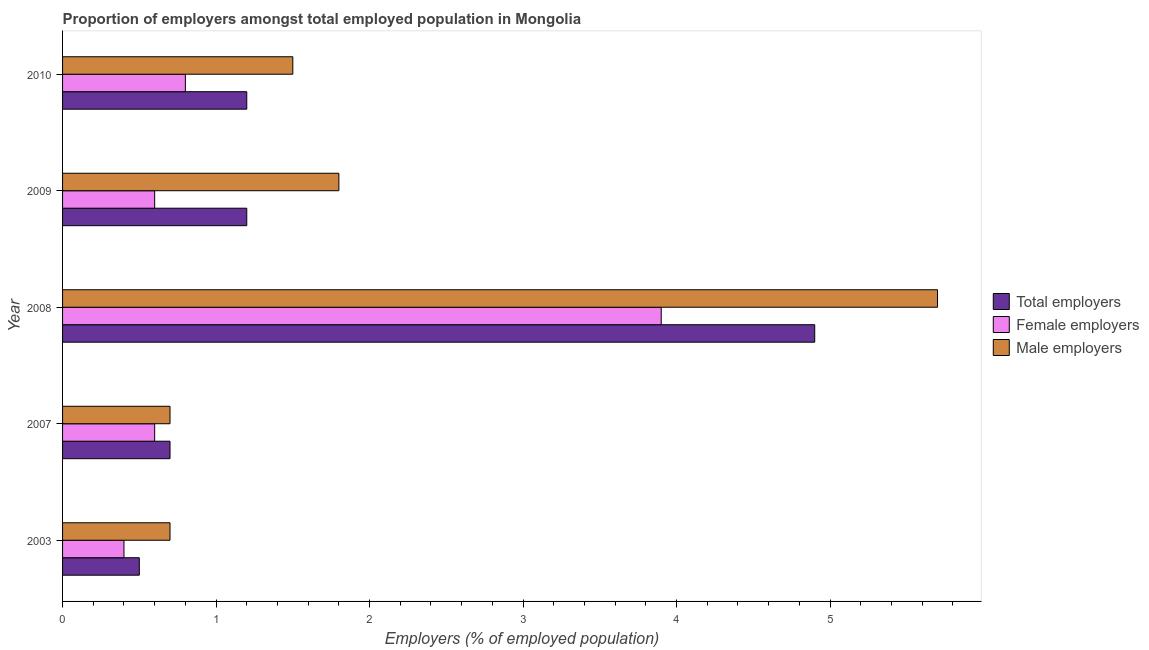Are the number of bars on each tick of the Y-axis equal?
Offer a terse response. Yes. How many bars are there on the 4th tick from the bottom?
Ensure brevity in your answer.  3. In how many cases, is the number of bars for a given year not equal to the number of legend labels?
Your answer should be compact. 0. What is the percentage of female employers in 2007?
Offer a very short reply. 0.6. Across all years, what is the maximum percentage of total employers?
Your answer should be very brief. 4.9. Across all years, what is the minimum percentage of male employers?
Offer a terse response. 0.7. What is the total percentage of female employers in the graph?
Ensure brevity in your answer.  6.3. What is the difference between the percentage of total employers in 2003 and that in 2007?
Provide a short and direct response. -0.2. What is the difference between the percentage of total employers in 2008 and the percentage of female employers in 2009?
Make the answer very short. 4.3. What is the average percentage of male employers per year?
Ensure brevity in your answer.  2.08. In the year 2008, what is the difference between the percentage of female employers and percentage of total employers?
Offer a terse response. -1. In how many years, is the percentage of female employers greater than 3.2 %?
Give a very brief answer. 1. What is the ratio of the percentage of total employers in 2003 to that in 2009?
Make the answer very short. 0.42. Is the percentage of male employers in 2003 less than that in 2009?
Ensure brevity in your answer.  Yes. Is the difference between the percentage of total employers in 2003 and 2010 greater than the difference between the percentage of male employers in 2003 and 2010?
Offer a terse response. Yes. What is the difference between the highest and the second highest percentage of male employers?
Make the answer very short. 3.9. What is the difference between the highest and the lowest percentage of female employers?
Your answer should be very brief. 3.5. Is the sum of the percentage of female employers in 2003 and 2009 greater than the maximum percentage of total employers across all years?
Your answer should be compact. No. What does the 1st bar from the top in 2010 represents?
Offer a very short reply. Male employers. What does the 3rd bar from the bottom in 2010 represents?
Offer a very short reply. Male employers. Are all the bars in the graph horizontal?
Offer a very short reply. Yes. How many years are there in the graph?
Provide a short and direct response. 5. Are the values on the major ticks of X-axis written in scientific E-notation?
Provide a succinct answer. No. Does the graph contain grids?
Keep it short and to the point. No. Where does the legend appear in the graph?
Offer a very short reply. Center right. How are the legend labels stacked?
Your answer should be very brief. Vertical. What is the title of the graph?
Provide a short and direct response. Proportion of employers amongst total employed population in Mongolia. What is the label or title of the X-axis?
Your response must be concise. Employers (% of employed population). What is the label or title of the Y-axis?
Offer a terse response. Year. What is the Employers (% of employed population) in Female employers in 2003?
Make the answer very short. 0.4. What is the Employers (% of employed population) of Male employers in 2003?
Keep it short and to the point. 0.7. What is the Employers (% of employed population) in Total employers in 2007?
Ensure brevity in your answer.  0.7. What is the Employers (% of employed population) of Female employers in 2007?
Offer a terse response. 0.6. What is the Employers (% of employed population) of Male employers in 2007?
Provide a succinct answer. 0.7. What is the Employers (% of employed population) of Total employers in 2008?
Provide a succinct answer. 4.9. What is the Employers (% of employed population) in Female employers in 2008?
Provide a succinct answer. 3.9. What is the Employers (% of employed population) in Male employers in 2008?
Your answer should be compact. 5.7. What is the Employers (% of employed population) of Total employers in 2009?
Your answer should be compact. 1.2. What is the Employers (% of employed population) in Female employers in 2009?
Make the answer very short. 0.6. What is the Employers (% of employed population) of Male employers in 2009?
Offer a terse response. 1.8. What is the Employers (% of employed population) of Total employers in 2010?
Ensure brevity in your answer.  1.2. What is the Employers (% of employed population) in Female employers in 2010?
Give a very brief answer. 0.8. Across all years, what is the maximum Employers (% of employed population) of Total employers?
Your response must be concise. 4.9. Across all years, what is the maximum Employers (% of employed population) in Female employers?
Provide a succinct answer. 3.9. Across all years, what is the maximum Employers (% of employed population) of Male employers?
Provide a succinct answer. 5.7. Across all years, what is the minimum Employers (% of employed population) in Total employers?
Provide a short and direct response. 0.5. Across all years, what is the minimum Employers (% of employed population) of Female employers?
Make the answer very short. 0.4. Across all years, what is the minimum Employers (% of employed population) in Male employers?
Ensure brevity in your answer.  0.7. What is the total Employers (% of employed population) in Total employers in the graph?
Your answer should be very brief. 8.5. What is the difference between the Employers (% of employed population) in Male employers in 2003 and that in 2008?
Your answer should be compact. -5. What is the difference between the Employers (% of employed population) of Female employers in 2007 and that in 2008?
Keep it short and to the point. -3.3. What is the difference between the Employers (% of employed population) of Male employers in 2007 and that in 2008?
Make the answer very short. -5. What is the difference between the Employers (% of employed population) of Female employers in 2007 and that in 2009?
Make the answer very short. 0. What is the difference between the Employers (% of employed population) in Male employers in 2007 and that in 2010?
Your answer should be very brief. -0.8. What is the difference between the Employers (% of employed population) in Total employers in 2008 and that in 2009?
Provide a short and direct response. 3.7. What is the difference between the Employers (% of employed population) of Total employers in 2008 and that in 2010?
Ensure brevity in your answer.  3.7. What is the difference between the Employers (% of employed population) in Female employers in 2008 and that in 2010?
Make the answer very short. 3.1. What is the difference between the Employers (% of employed population) of Male employers in 2008 and that in 2010?
Ensure brevity in your answer.  4.2. What is the difference between the Employers (% of employed population) of Male employers in 2009 and that in 2010?
Your response must be concise. 0.3. What is the difference between the Employers (% of employed population) of Total employers in 2003 and the Employers (% of employed population) of Female employers in 2007?
Provide a short and direct response. -0.1. What is the difference between the Employers (% of employed population) in Total employers in 2003 and the Employers (% of employed population) in Female employers in 2008?
Give a very brief answer. -3.4. What is the difference between the Employers (% of employed population) of Female employers in 2003 and the Employers (% of employed population) of Male employers in 2008?
Keep it short and to the point. -5.3. What is the difference between the Employers (% of employed population) of Total employers in 2003 and the Employers (% of employed population) of Male employers in 2009?
Ensure brevity in your answer.  -1.3. What is the difference between the Employers (% of employed population) in Female employers in 2003 and the Employers (% of employed population) in Male employers in 2009?
Provide a succinct answer. -1.4. What is the difference between the Employers (% of employed population) in Total employers in 2007 and the Employers (% of employed population) in Female employers in 2008?
Offer a very short reply. -3.2. What is the difference between the Employers (% of employed population) of Total employers in 2007 and the Employers (% of employed population) of Male employers in 2008?
Your answer should be compact. -5. What is the difference between the Employers (% of employed population) in Female employers in 2007 and the Employers (% of employed population) in Male employers in 2008?
Offer a very short reply. -5.1. What is the difference between the Employers (% of employed population) in Total employers in 2007 and the Employers (% of employed population) in Female employers in 2009?
Your answer should be compact. 0.1. What is the difference between the Employers (% of employed population) of Total employers in 2007 and the Employers (% of employed population) of Male employers in 2009?
Ensure brevity in your answer.  -1.1. What is the difference between the Employers (% of employed population) of Total employers in 2007 and the Employers (% of employed population) of Female employers in 2010?
Ensure brevity in your answer.  -0.1. What is the difference between the Employers (% of employed population) in Total employers in 2007 and the Employers (% of employed population) in Male employers in 2010?
Make the answer very short. -0.8. What is the difference between the Employers (% of employed population) of Female employers in 2007 and the Employers (% of employed population) of Male employers in 2010?
Provide a succinct answer. -0.9. What is the difference between the Employers (% of employed population) in Total employers in 2008 and the Employers (% of employed population) in Male employers in 2009?
Keep it short and to the point. 3.1. What is the difference between the Employers (% of employed population) of Female employers in 2008 and the Employers (% of employed population) of Male employers in 2010?
Your answer should be very brief. 2.4. What is the difference between the Employers (% of employed population) in Female employers in 2009 and the Employers (% of employed population) in Male employers in 2010?
Ensure brevity in your answer.  -0.9. What is the average Employers (% of employed population) of Female employers per year?
Your response must be concise. 1.26. What is the average Employers (% of employed population) of Male employers per year?
Offer a terse response. 2.08. In the year 2003, what is the difference between the Employers (% of employed population) of Female employers and Employers (% of employed population) of Male employers?
Provide a succinct answer. -0.3. In the year 2007, what is the difference between the Employers (% of employed population) in Total employers and Employers (% of employed population) in Female employers?
Your answer should be compact. 0.1. In the year 2007, what is the difference between the Employers (% of employed population) in Total employers and Employers (% of employed population) in Male employers?
Offer a very short reply. 0. In the year 2008, what is the difference between the Employers (% of employed population) of Female employers and Employers (% of employed population) of Male employers?
Offer a very short reply. -1.8. In the year 2009, what is the difference between the Employers (% of employed population) of Total employers and Employers (% of employed population) of Male employers?
Your response must be concise. -0.6. In the year 2009, what is the difference between the Employers (% of employed population) in Female employers and Employers (% of employed population) in Male employers?
Keep it short and to the point. -1.2. In the year 2010, what is the difference between the Employers (% of employed population) of Total employers and Employers (% of employed population) of Female employers?
Offer a very short reply. 0.4. In the year 2010, what is the difference between the Employers (% of employed population) of Total employers and Employers (% of employed population) of Male employers?
Your answer should be very brief. -0.3. What is the ratio of the Employers (% of employed population) of Total employers in 2003 to that in 2007?
Your answer should be compact. 0.71. What is the ratio of the Employers (% of employed population) of Male employers in 2003 to that in 2007?
Offer a very short reply. 1. What is the ratio of the Employers (% of employed population) of Total employers in 2003 to that in 2008?
Ensure brevity in your answer.  0.1. What is the ratio of the Employers (% of employed population) of Female employers in 2003 to that in 2008?
Give a very brief answer. 0.1. What is the ratio of the Employers (% of employed population) of Male employers in 2003 to that in 2008?
Make the answer very short. 0.12. What is the ratio of the Employers (% of employed population) in Total employers in 2003 to that in 2009?
Ensure brevity in your answer.  0.42. What is the ratio of the Employers (% of employed population) of Female employers in 2003 to that in 2009?
Provide a short and direct response. 0.67. What is the ratio of the Employers (% of employed population) of Male employers in 2003 to that in 2009?
Give a very brief answer. 0.39. What is the ratio of the Employers (% of employed population) in Total employers in 2003 to that in 2010?
Offer a very short reply. 0.42. What is the ratio of the Employers (% of employed population) of Female employers in 2003 to that in 2010?
Your answer should be compact. 0.5. What is the ratio of the Employers (% of employed population) in Male employers in 2003 to that in 2010?
Offer a very short reply. 0.47. What is the ratio of the Employers (% of employed population) in Total employers in 2007 to that in 2008?
Your answer should be compact. 0.14. What is the ratio of the Employers (% of employed population) in Female employers in 2007 to that in 2008?
Give a very brief answer. 0.15. What is the ratio of the Employers (% of employed population) in Male employers in 2007 to that in 2008?
Provide a short and direct response. 0.12. What is the ratio of the Employers (% of employed population) of Total employers in 2007 to that in 2009?
Offer a very short reply. 0.58. What is the ratio of the Employers (% of employed population) of Male employers in 2007 to that in 2009?
Provide a short and direct response. 0.39. What is the ratio of the Employers (% of employed population) in Total employers in 2007 to that in 2010?
Provide a short and direct response. 0.58. What is the ratio of the Employers (% of employed population) of Female employers in 2007 to that in 2010?
Your answer should be compact. 0.75. What is the ratio of the Employers (% of employed population) of Male employers in 2007 to that in 2010?
Give a very brief answer. 0.47. What is the ratio of the Employers (% of employed population) in Total employers in 2008 to that in 2009?
Offer a very short reply. 4.08. What is the ratio of the Employers (% of employed population) in Male employers in 2008 to that in 2009?
Offer a terse response. 3.17. What is the ratio of the Employers (% of employed population) of Total employers in 2008 to that in 2010?
Offer a very short reply. 4.08. What is the ratio of the Employers (% of employed population) of Female employers in 2008 to that in 2010?
Make the answer very short. 4.88. What is the ratio of the Employers (% of employed population) of Female employers in 2009 to that in 2010?
Offer a very short reply. 0.75. What is the ratio of the Employers (% of employed population) of Male employers in 2009 to that in 2010?
Offer a very short reply. 1.2. What is the difference between the highest and the second highest Employers (% of employed population) in Total employers?
Your answer should be very brief. 3.7. What is the difference between the highest and the second highest Employers (% of employed population) in Female employers?
Make the answer very short. 3.1. What is the difference between the highest and the second highest Employers (% of employed population) of Male employers?
Your answer should be very brief. 3.9. What is the difference between the highest and the lowest Employers (% of employed population) of Total employers?
Your answer should be compact. 4.4. What is the difference between the highest and the lowest Employers (% of employed population) in Male employers?
Keep it short and to the point. 5. 